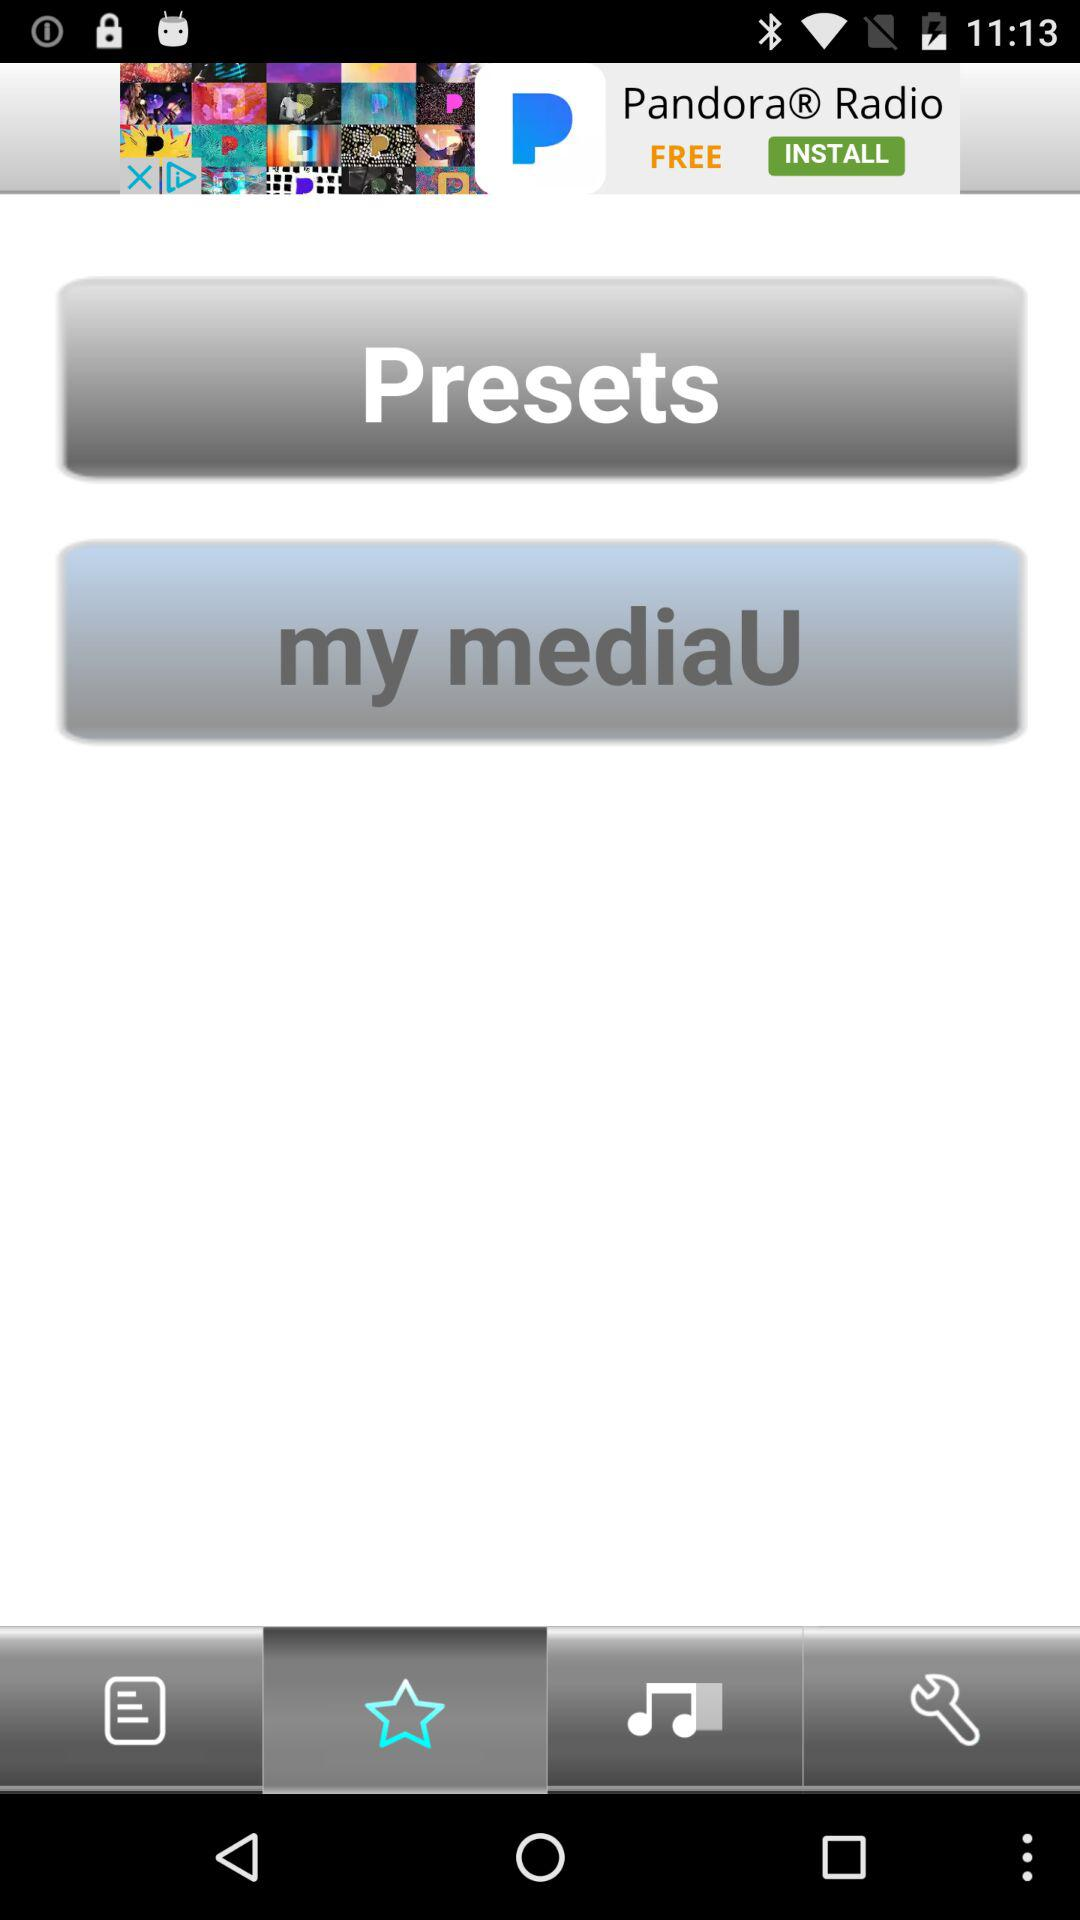How many "Presets" are there?
When the provided information is insufficient, respond with <no answer>. <no answer> 